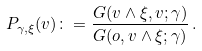<formula> <loc_0><loc_0><loc_500><loc_500>P _ { \gamma , \xi } ( v ) \colon = \frac { G ( v \wedge \xi , v ; \gamma ) } { G ( o , v \wedge \xi ; \gamma ) } \, .</formula> 